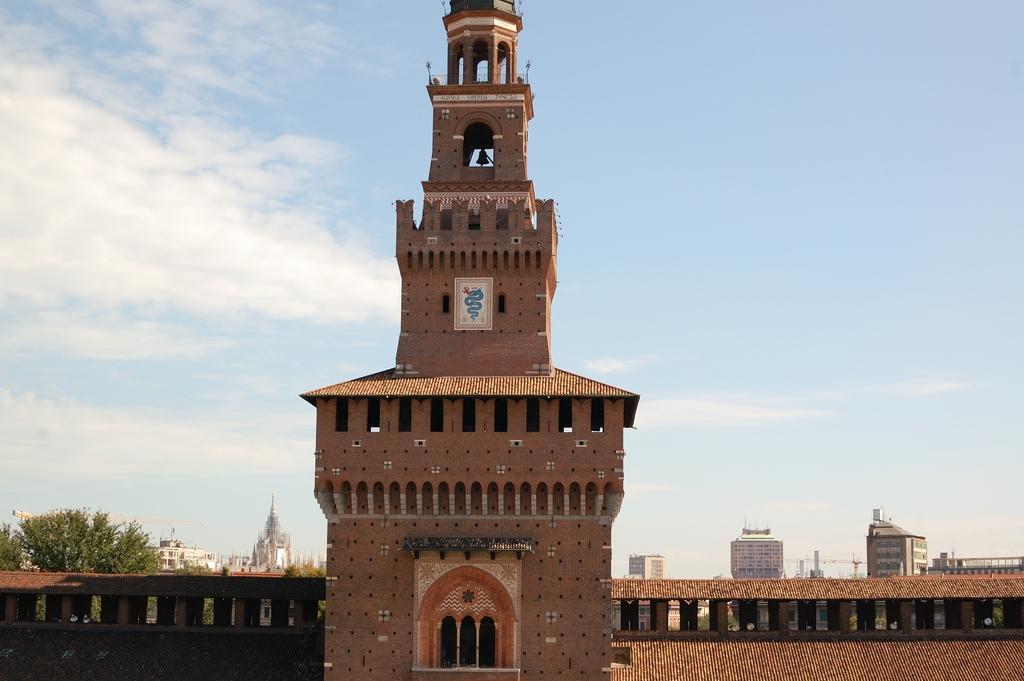How would you summarize this image in a sentence or two? In the foreground of the picture there is a building. In the center it is looking like a steeple. On the left there are buildings and trees. On the right there are buildings. In the background and top it is sky. 